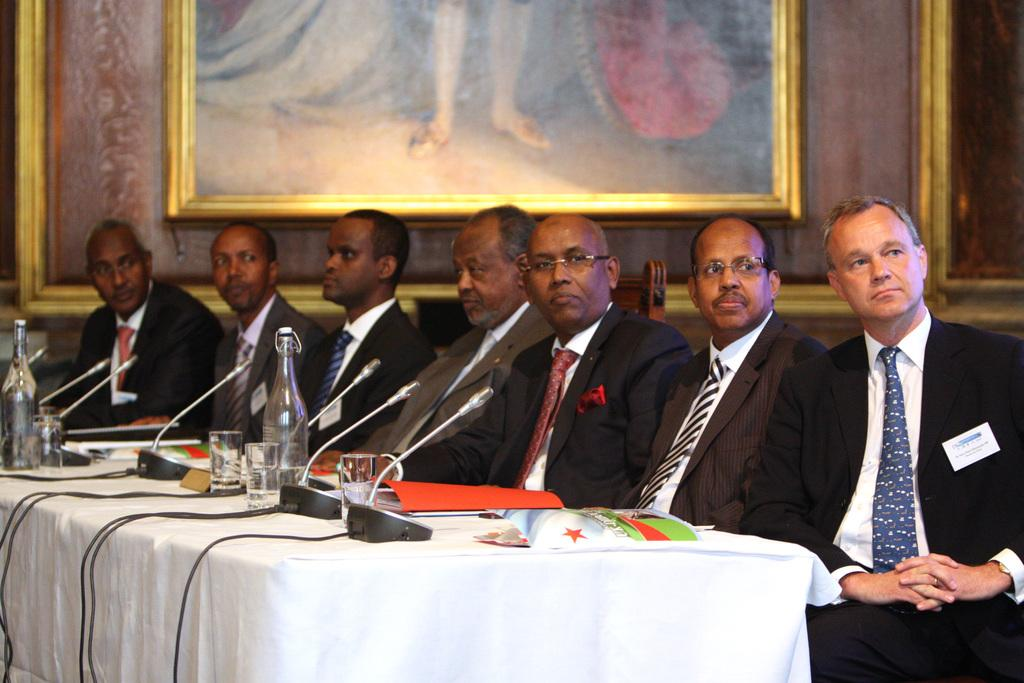What are the people in the image doing? The people in the image are sitting. What objects are present in the image that are used for amplifying sound? There are microphones (mics) in the image. What type of containers are visible in the image? There are bottles and glasses in the image. What can be seen on a surface in the image? There are objects on a table in the image. What can be seen in the background of the image? There are frames in the background of the image. What type of mist can be seen surrounding the people in the image? There is no mist present in the image; it is a clear scene with people sitting and other objects visible. 